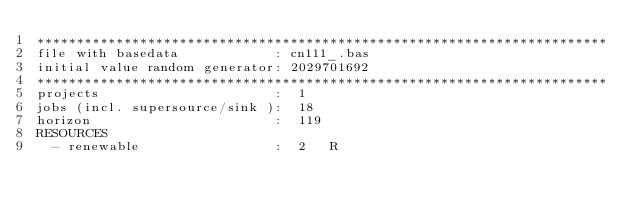<code> <loc_0><loc_0><loc_500><loc_500><_ObjectiveC_>************************************************************************
file with basedata            : cn111_.bas
initial value random generator: 2029701692
************************************************************************
projects                      :  1
jobs (incl. supersource/sink ):  18
horizon                       :  119
RESOURCES
  - renewable                 :  2   R</code> 